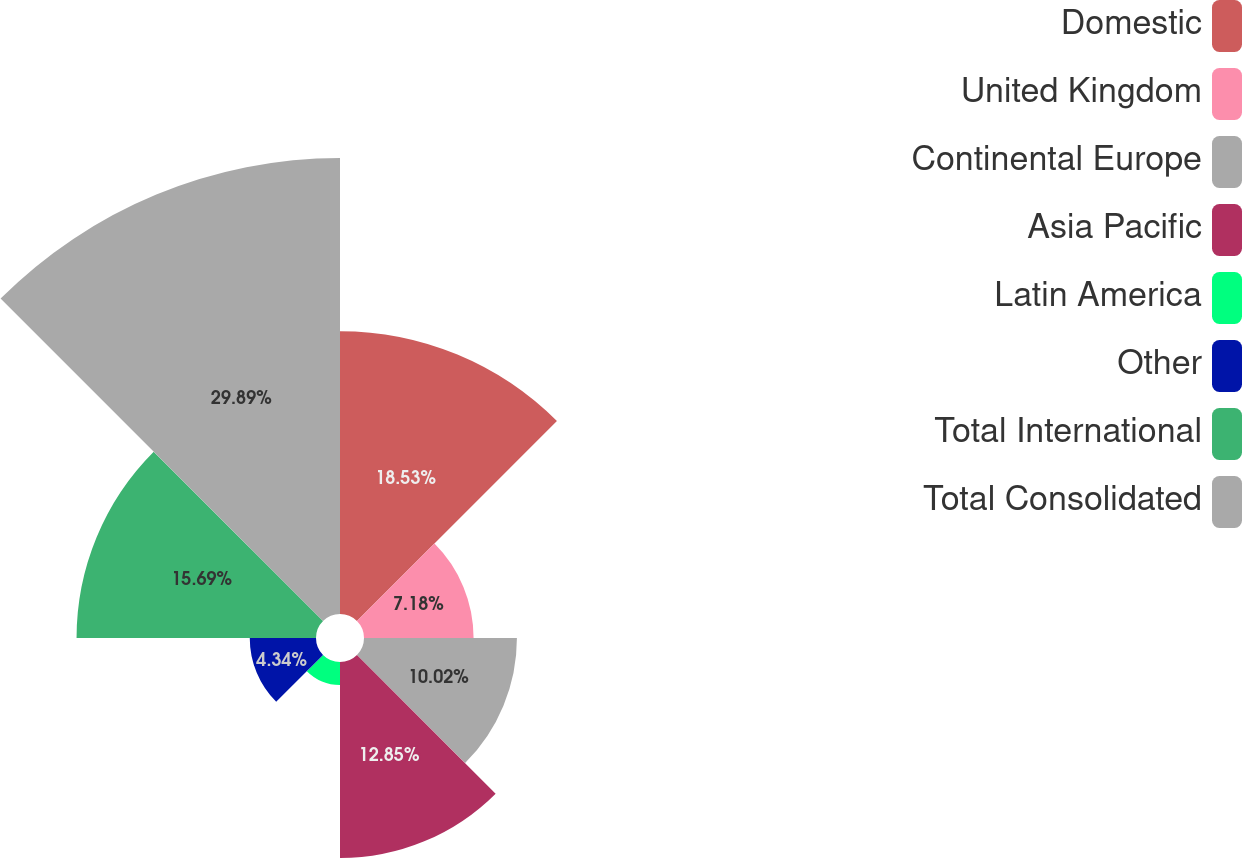Convert chart to OTSL. <chart><loc_0><loc_0><loc_500><loc_500><pie_chart><fcel>Domestic<fcel>United Kingdom<fcel>Continental Europe<fcel>Asia Pacific<fcel>Latin America<fcel>Other<fcel>Total International<fcel>Total Consolidated<nl><fcel>18.53%<fcel>7.18%<fcel>10.02%<fcel>12.85%<fcel>1.5%<fcel>4.34%<fcel>15.69%<fcel>29.88%<nl></chart> 